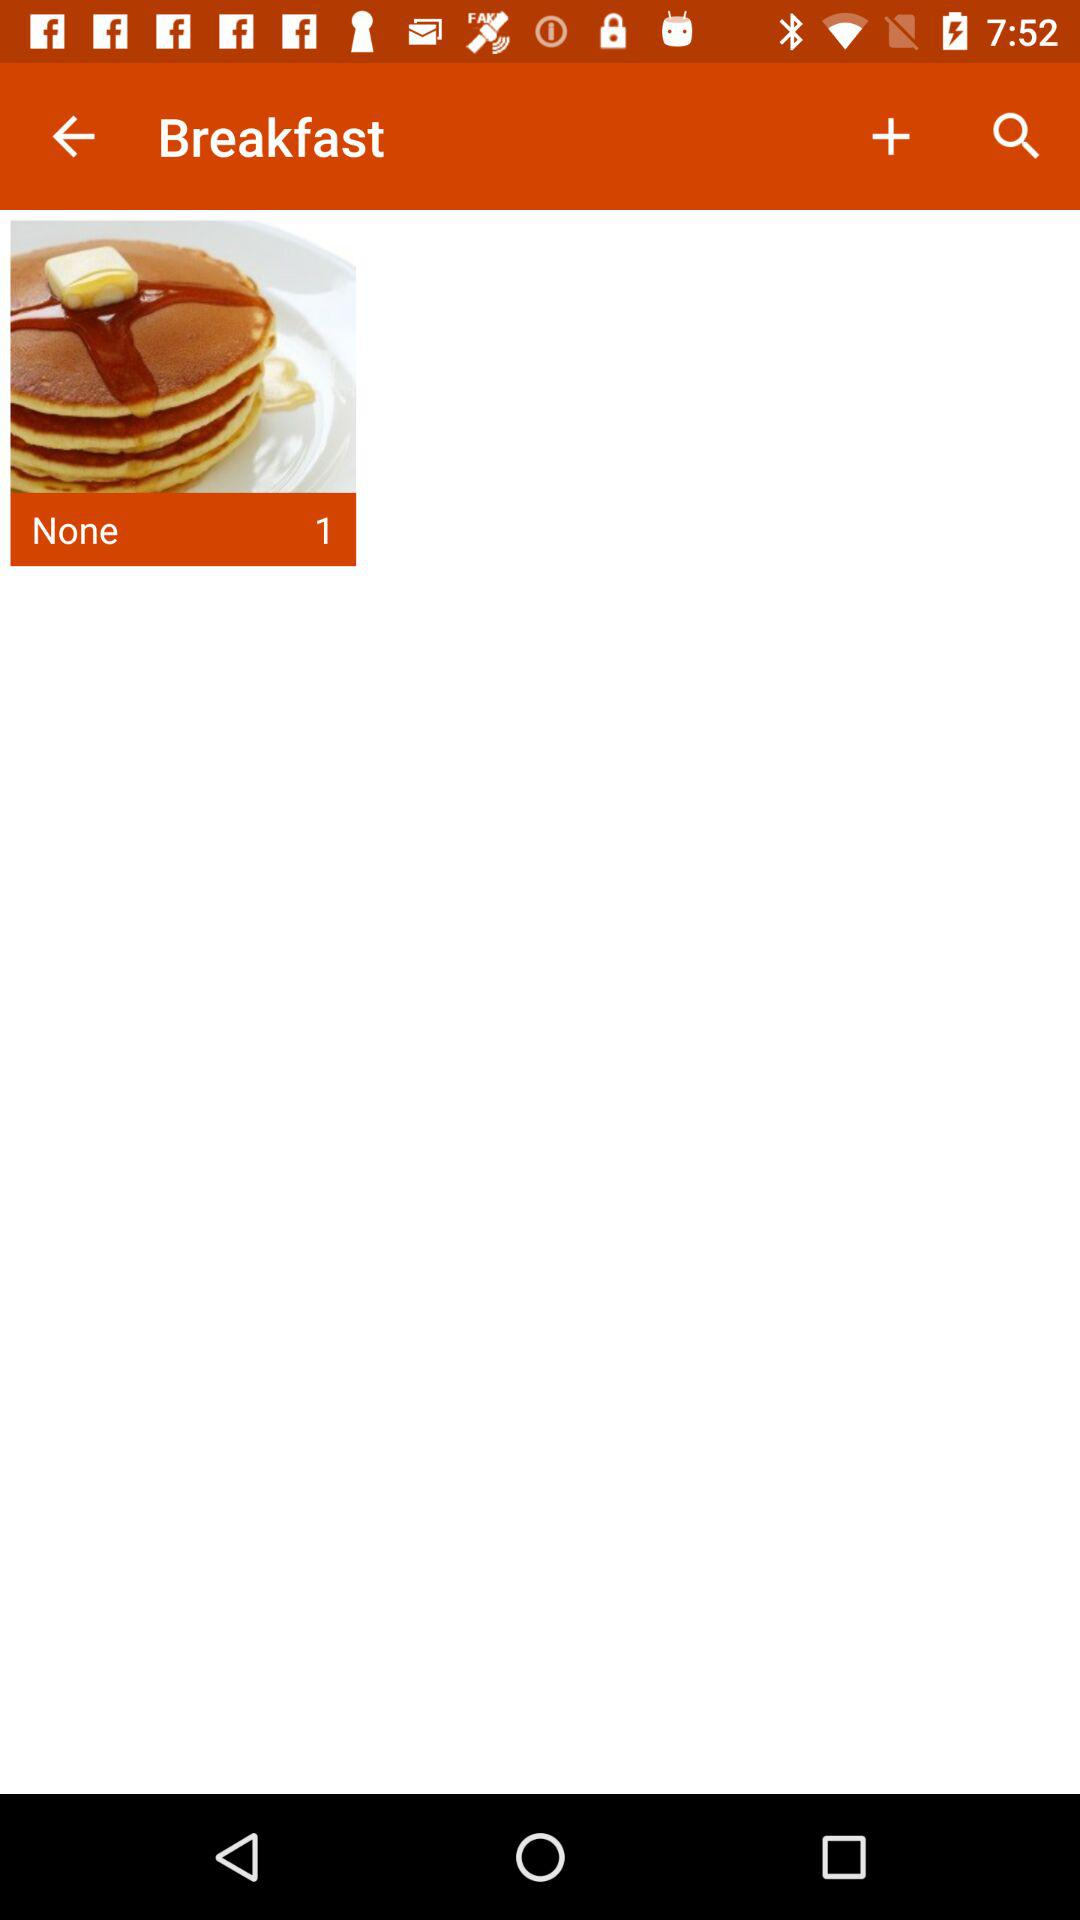What is the name of the application?
When the provided information is insufficient, respond with <no answer>. <no answer> 